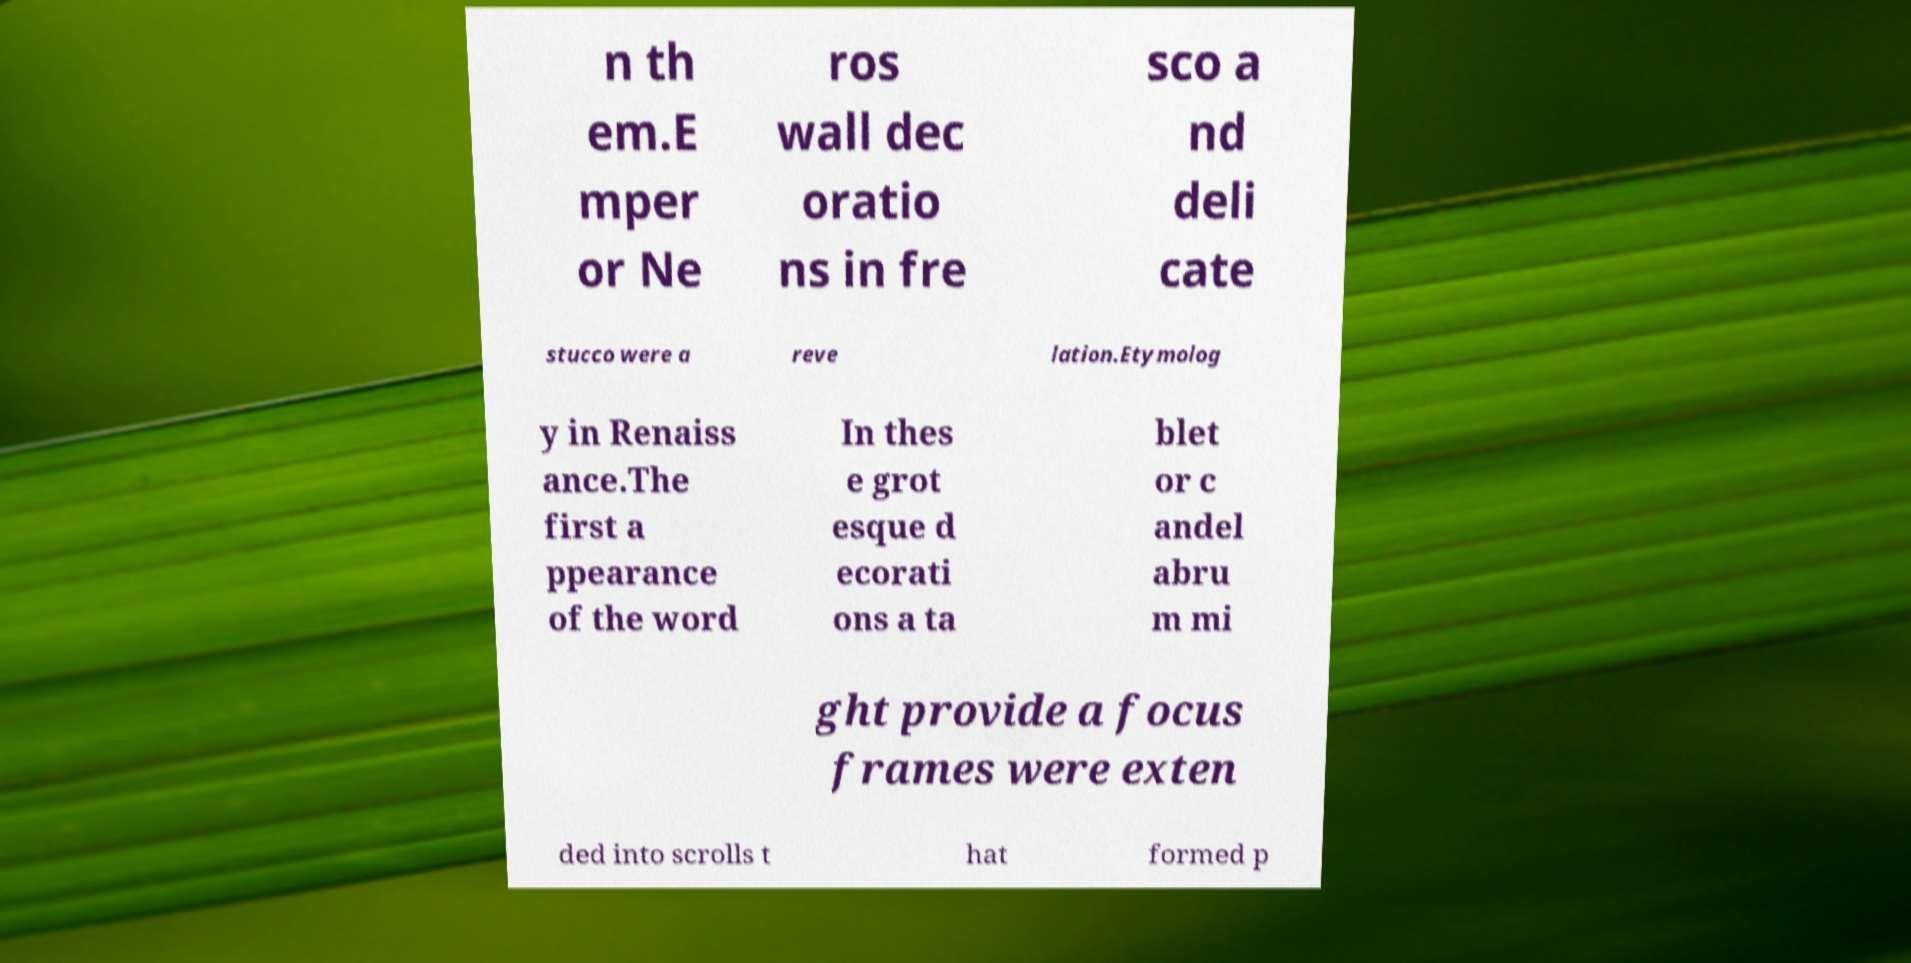Please identify and transcribe the text found in this image. n th em.E mper or Ne ros wall dec oratio ns in fre sco a nd deli cate stucco were a reve lation.Etymolog y in Renaiss ance.The first a ppearance of the word In thes e grot esque d ecorati ons a ta blet or c andel abru m mi ght provide a focus frames were exten ded into scrolls t hat formed p 